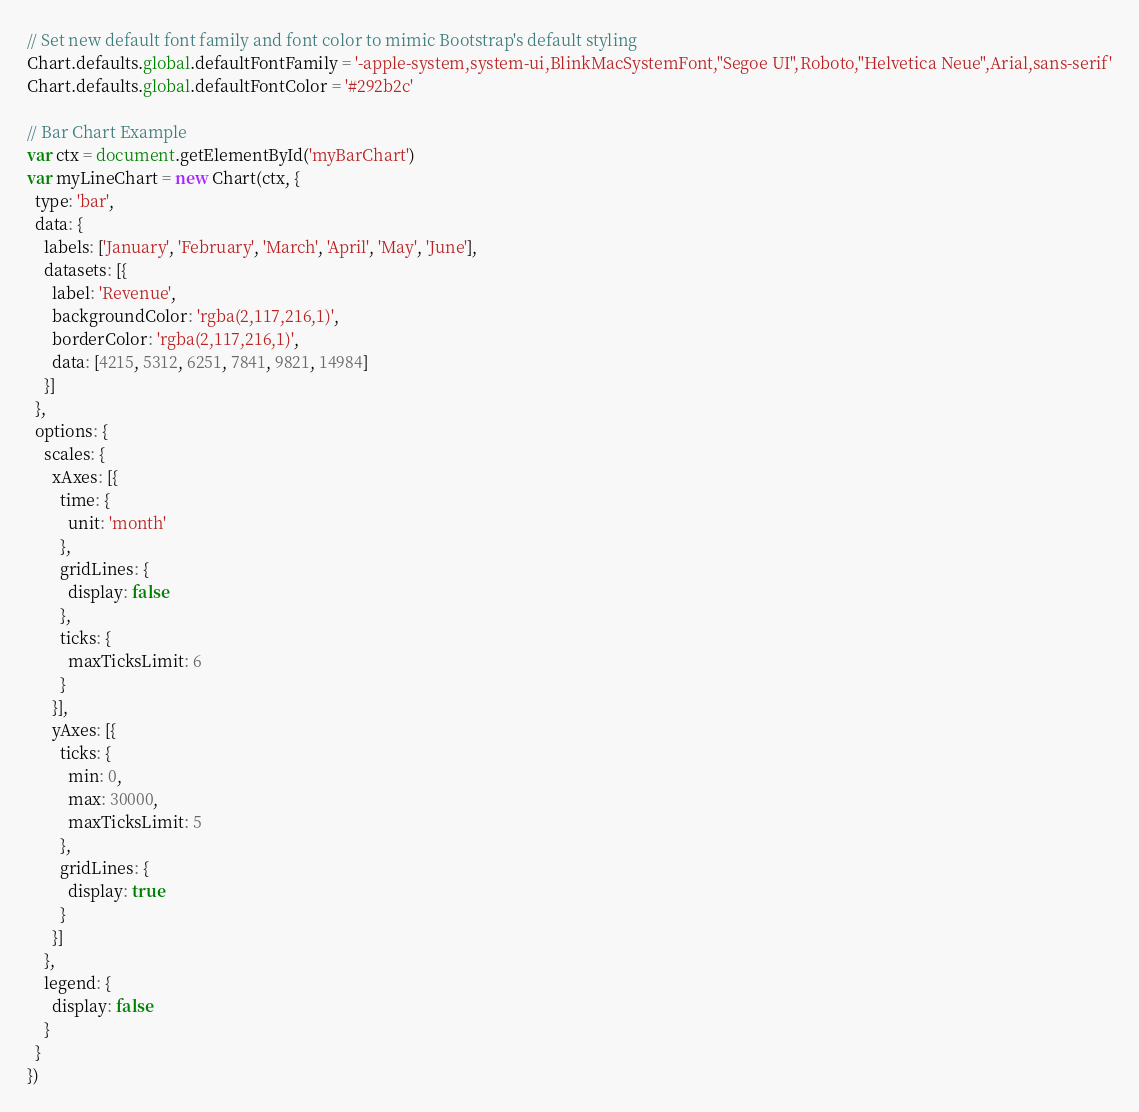<code> <loc_0><loc_0><loc_500><loc_500><_JavaScript_>// Set new default font family and font color to mimic Bootstrap's default styling
Chart.defaults.global.defaultFontFamily = '-apple-system,system-ui,BlinkMacSystemFont,"Segoe UI",Roboto,"Helvetica Neue",Arial,sans-serif'
Chart.defaults.global.defaultFontColor = '#292b2c'

// Bar Chart Example
var ctx = document.getElementById('myBarChart')
var myLineChart = new Chart(ctx, {
  type: 'bar',
  data: {
    labels: ['January', 'February', 'March', 'April', 'May', 'June'],
    datasets: [{
      label: 'Revenue',
      backgroundColor: 'rgba(2,117,216,1)',
      borderColor: 'rgba(2,117,216,1)',
      data: [4215, 5312, 6251, 7841, 9821, 14984]
    }]
  },
  options: {
    scales: {
      xAxes: [{
        time: {
          unit: 'month'
        },
        gridLines: {
          display: false
        },
        ticks: {
          maxTicksLimit: 6
        }
      }],
      yAxes: [{
        ticks: {
          min: 0,
          max: 30000,
          maxTicksLimit: 5
        },
        gridLines: {
          display: true
        }
      }]
    },
    legend: {
      display: false
    }
  }
})
</code> 